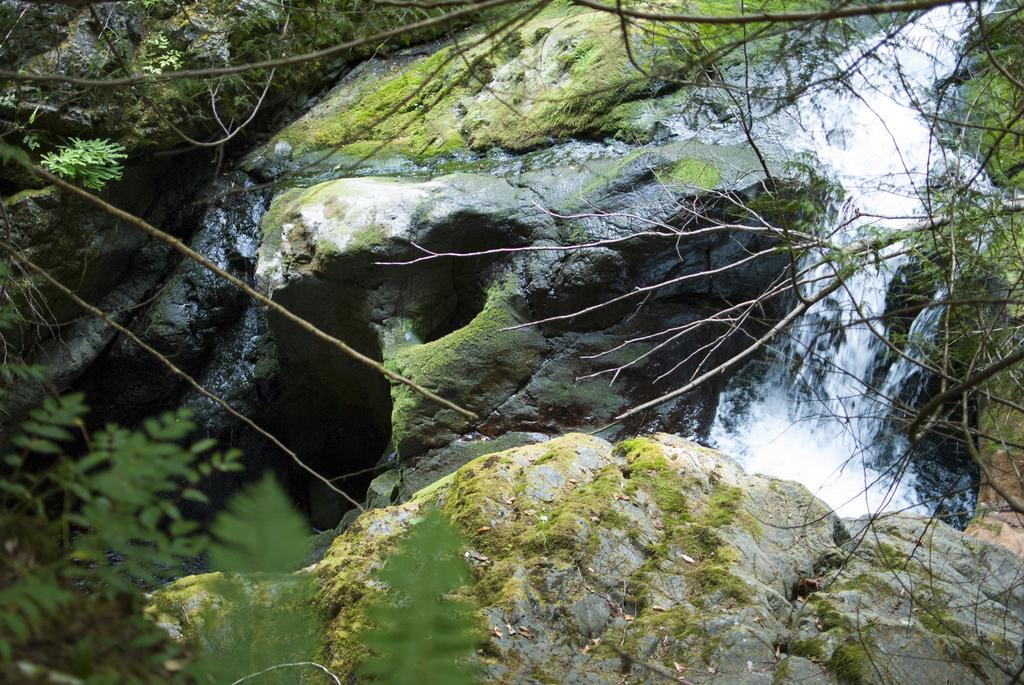What type of natural formation is covered with algae in the image? There are rocks covered with algae in the image. What body of water might be depicted in the image? The image appears to depict water. What type of plant material can be seen in the image? Branches and leaves are present in the image. What type of soda is being poured into the rocks in the image? There is no soda present in the image; it depicts rocks covered with algae and a body of water. Can you tell me the name of the father in the image? There is no person, let alone a father, present in the image. 